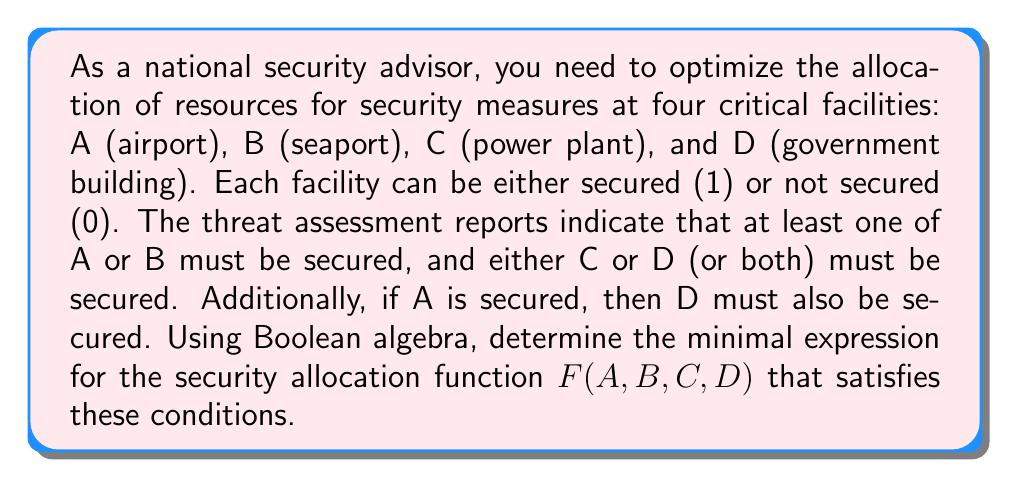Can you solve this math problem? Let's approach this step-by-step:

1) First, let's express the given conditions in Boolean algebra:
   - At least one of A or B must be secured: $A + B$
   - Either C or D (or both) must be secured: $C + D$
   - If A is secured, then D must be secured: $A \rightarrow D$ or $\overline{A} + D$

2) The security allocation function $F(A,B,C,D)$ must satisfy all these conditions:
   $F(A,B,C,D) = (A + B)(C + D)(\overline{A} + D)$

3) Expand this expression:
   $F(A,B,C,D) = (AC + AD + BC + BD)(\overline{A} + D)$

4) Distribute $(\overline{A} + D)$:
   $F(A,B,C,D) = AC\overline{A} + ACD + BC\overline{A} + BCD + AD\overline{A} + AD + BD\overline{A} + BD$

5) Simplify:
   - $AC\overline{A} = 0$
   - $AD\overline{A} = 0$
   - $BD\overline{A} + BD = BD$

6) The simplified expression becomes:
   $F(A,B,C,D) = ACD + BC\overline{A} + BCD + AD + BD$

7) Apply Boolean algebra rules to further simplify:
   - $ACD + AD = AD$ (absorption law)
   - $BCD + BD = BD$ (absorption law)

8) The final minimized expression is:
   $F(A,B,C,D) = AD + BC\overline{A} + BD$

This expression represents the minimal form of the security allocation function that satisfies all the given conditions.
Answer: $F(A,B,C,D) = AD + BC\overline{A} + BD$ 